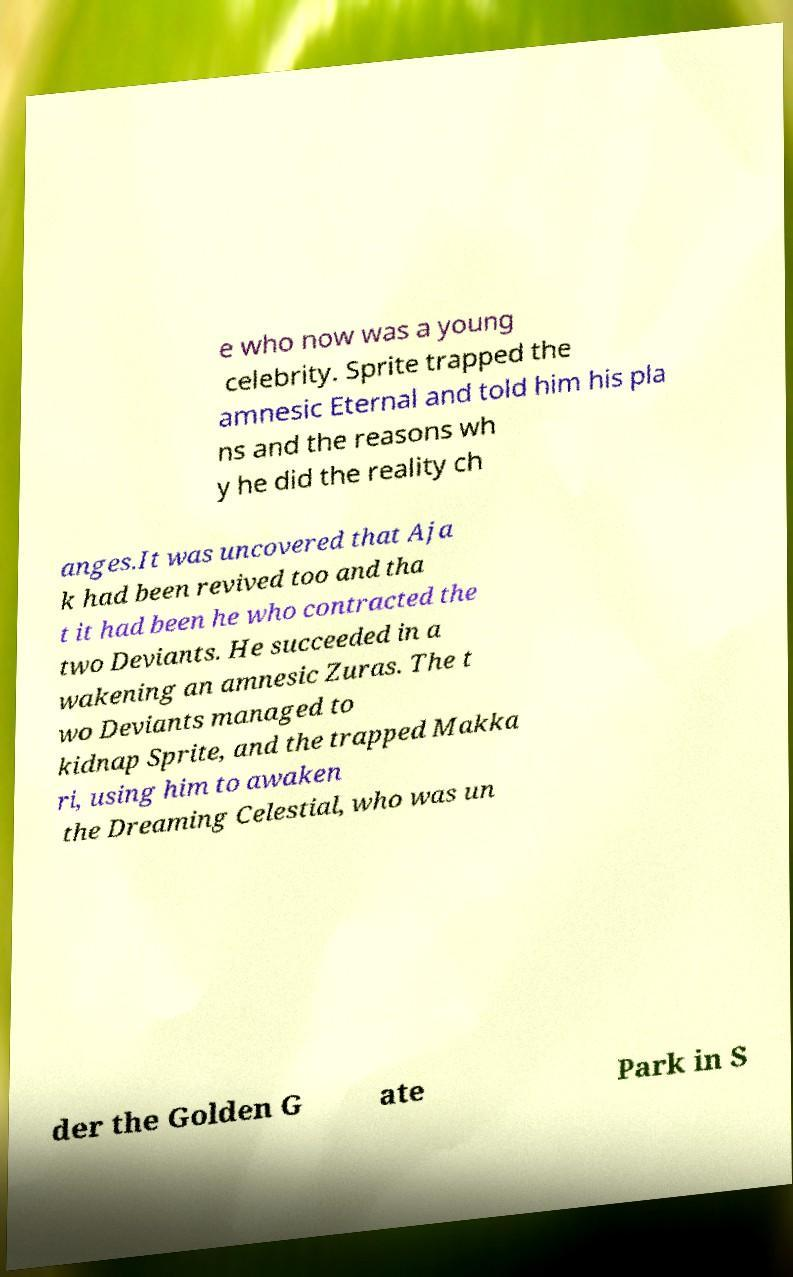Could you assist in decoding the text presented in this image and type it out clearly? e who now was a young celebrity. Sprite trapped the amnesic Eternal and told him his pla ns and the reasons wh y he did the reality ch anges.It was uncovered that Aja k had been revived too and tha t it had been he who contracted the two Deviants. He succeeded in a wakening an amnesic Zuras. The t wo Deviants managed to kidnap Sprite, and the trapped Makka ri, using him to awaken the Dreaming Celestial, who was un der the Golden G ate Park in S 